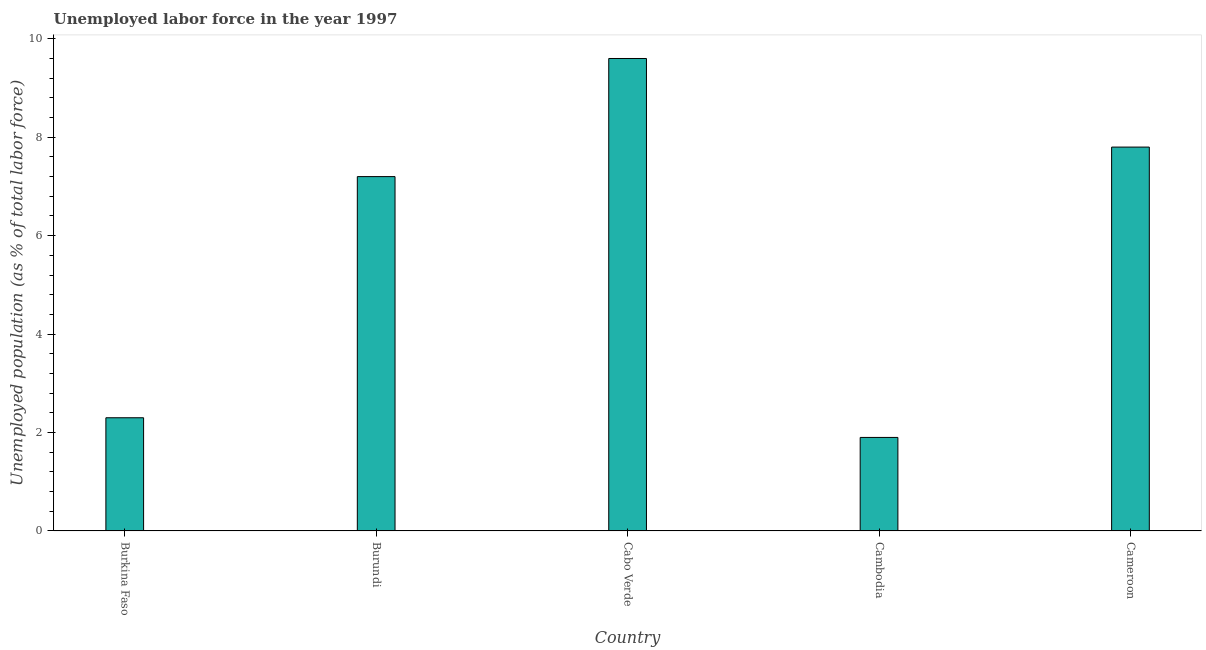Does the graph contain grids?
Make the answer very short. No. What is the title of the graph?
Offer a terse response. Unemployed labor force in the year 1997. What is the label or title of the X-axis?
Your answer should be very brief. Country. What is the label or title of the Y-axis?
Offer a very short reply. Unemployed population (as % of total labor force). What is the total unemployed population in Cambodia?
Your answer should be compact. 1.9. Across all countries, what is the maximum total unemployed population?
Your answer should be compact. 9.6. Across all countries, what is the minimum total unemployed population?
Keep it short and to the point. 1.9. In which country was the total unemployed population maximum?
Your answer should be compact. Cabo Verde. In which country was the total unemployed population minimum?
Give a very brief answer. Cambodia. What is the sum of the total unemployed population?
Provide a succinct answer. 28.8. What is the average total unemployed population per country?
Provide a succinct answer. 5.76. What is the median total unemployed population?
Offer a very short reply. 7.2. In how many countries, is the total unemployed population greater than 2 %?
Provide a succinct answer. 4. What is the ratio of the total unemployed population in Burkina Faso to that in Cambodia?
Provide a short and direct response. 1.21. Is the total unemployed population in Burundi less than that in Cambodia?
Give a very brief answer. No. What is the difference between the highest and the second highest total unemployed population?
Provide a short and direct response. 1.8. Is the sum of the total unemployed population in Burkina Faso and Burundi greater than the maximum total unemployed population across all countries?
Keep it short and to the point. No. What is the difference between the highest and the lowest total unemployed population?
Ensure brevity in your answer.  7.7. How many bars are there?
Offer a terse response. 5. How many countries are there in the graph?
Offer a terse response. 5. What is the Unemployed population (as % of total labor force) in Burkina Faso?
Keep it short and to the point. 2.3. What is the Unemployed population (as % of total labor force) in Burundi?
Make the answer very short. 7.2. What is the Unemployed population (as % of total labor force) in Cabo Verde?
Give a very brief answer. 9.6. What is the Unemployed population (as % of total labor force) of Cambodia?
Keep it short and to the point. 1.9. What is the Unemployed population (as % of total labor force) of Cameroon?
Offer a very short reply. 7.8. What is the difference between the Unemployed population (as % of total labor force) in Burkina Faso and Cambodia?
Ensure brevity in your answer.  0.4. What is the difference between the Unemployed population (as % of total labor force) in Burundi and Cambodia?
Ensure brevity in your answer.  5.3. What is the difference between the Unemployed population (as % of total labor force) in Burundi and Cameroon?
Your response must be concise. -0.6. What is the difference between the Unemployed population (as % of total labor force) in Cabo Verde and Cameroon?
Make the answer very short. 1.8. What is the difference between the Unemployed population (as % of total labor force) in Cambodia and Cameroon?
Your response must be concise. -5.9. What is the ratio of the Unemployed population (as % of total labor force) in Burkina Faso to that in Burundi?
Provide a short and direct response. 0.32. What is the ratio of the Unemployed population (as % of total labor force) in Burkina Faso to that in Cabo Verde?
Your answer should be compact. 0.24. What is the ratio of the Unemployed population (as % of total labor force) in Burkina Faso to that in Cambodia?
Make the answer very short. 1.21. What is the ratio of the Unemployed population (as % of total labor force) in Burkina Faso to that in Cameroon?
Your answer should be compact. 0.29. What is the ratio of the Unemployed population (as % of total labor force) in Burundi to that in Cabo Verde?
Your answer should be compact. 0.75. What is the ratio of the Unemployed population (as % of total labor force) in Burundi to that in Cambodia?
Ensure brevity in your answer.  3.79. What is the ratio of the Unemployed population (as % of total labor force) in Burundi to that in Cameroon?
Your answer should be compact. 0.92. What is the ratio of the Unemployed population (as % of total labor force) in Cabo Verde to that in Cambodia?
Provide a short and direct response. 5.05. What is the ratio of the Unemployed population (as % of total labor force) in Cabo Verde to that in Cameroon?
Your answer should be compact. 1.23. What is the ratio of the Unemployed population (as % of total labor force) in Cambodia to that in Cameroon?
Offer a very short reply. 0.24. 